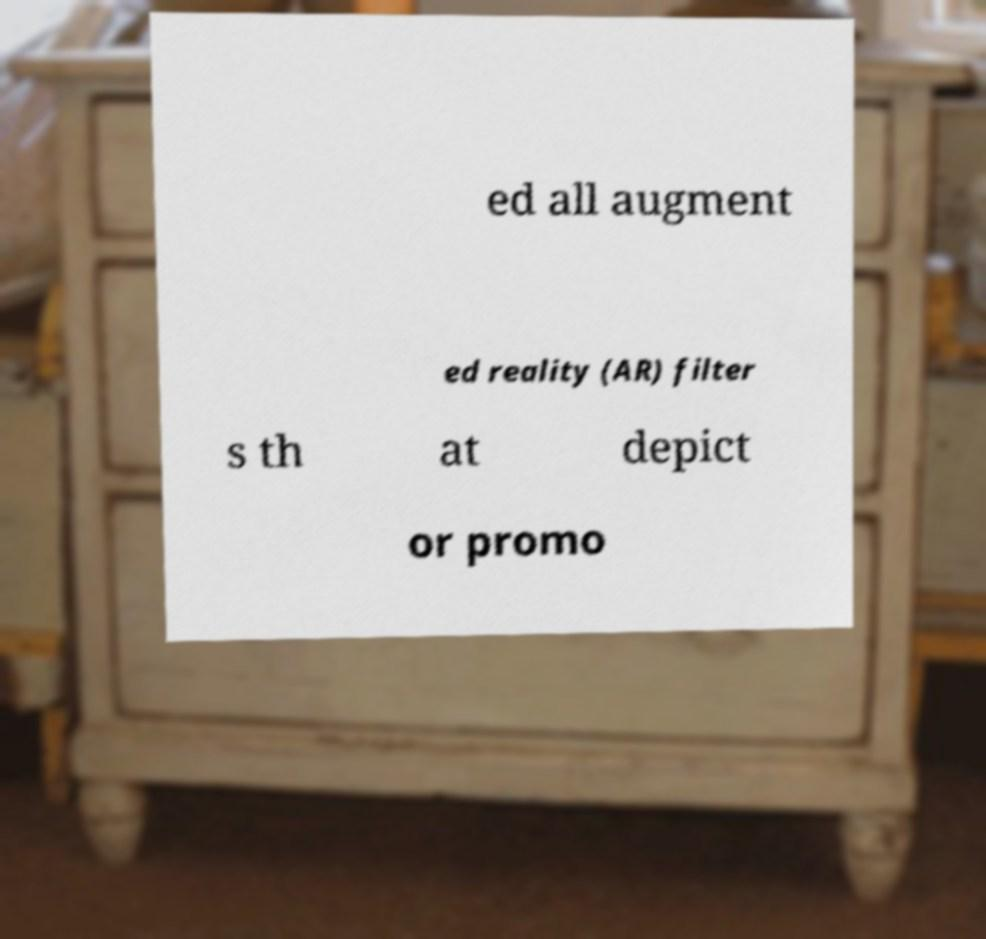Could you assist in decoding the text presented in this image and type it out clearly? ed all augment ed reality (AR) filter s th at depict or promo 